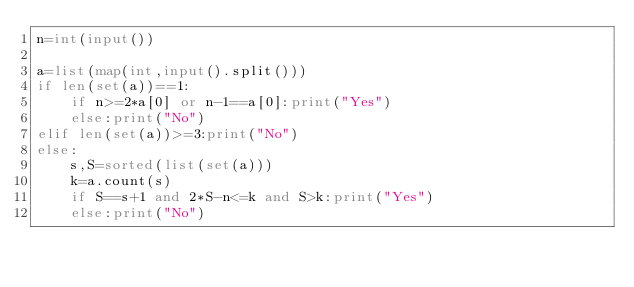<code> <loc_0><loc_0><loc_500><loc_500><_Python_>n=int(input())

a=list(map(int,input().split()))
if len(set(a))==1:
    if n>=2*a[0] or n-1==a[0]:print("Yes")
    else:print("No")
elif len(set(a))>=3:print("No")
else:
    s,S=sorted(list(set(a)))
    k=a.count(s)
    if S==s+1 and 2*S-n<=k and S>k:print("Yes")
    else:print("No")</code> 